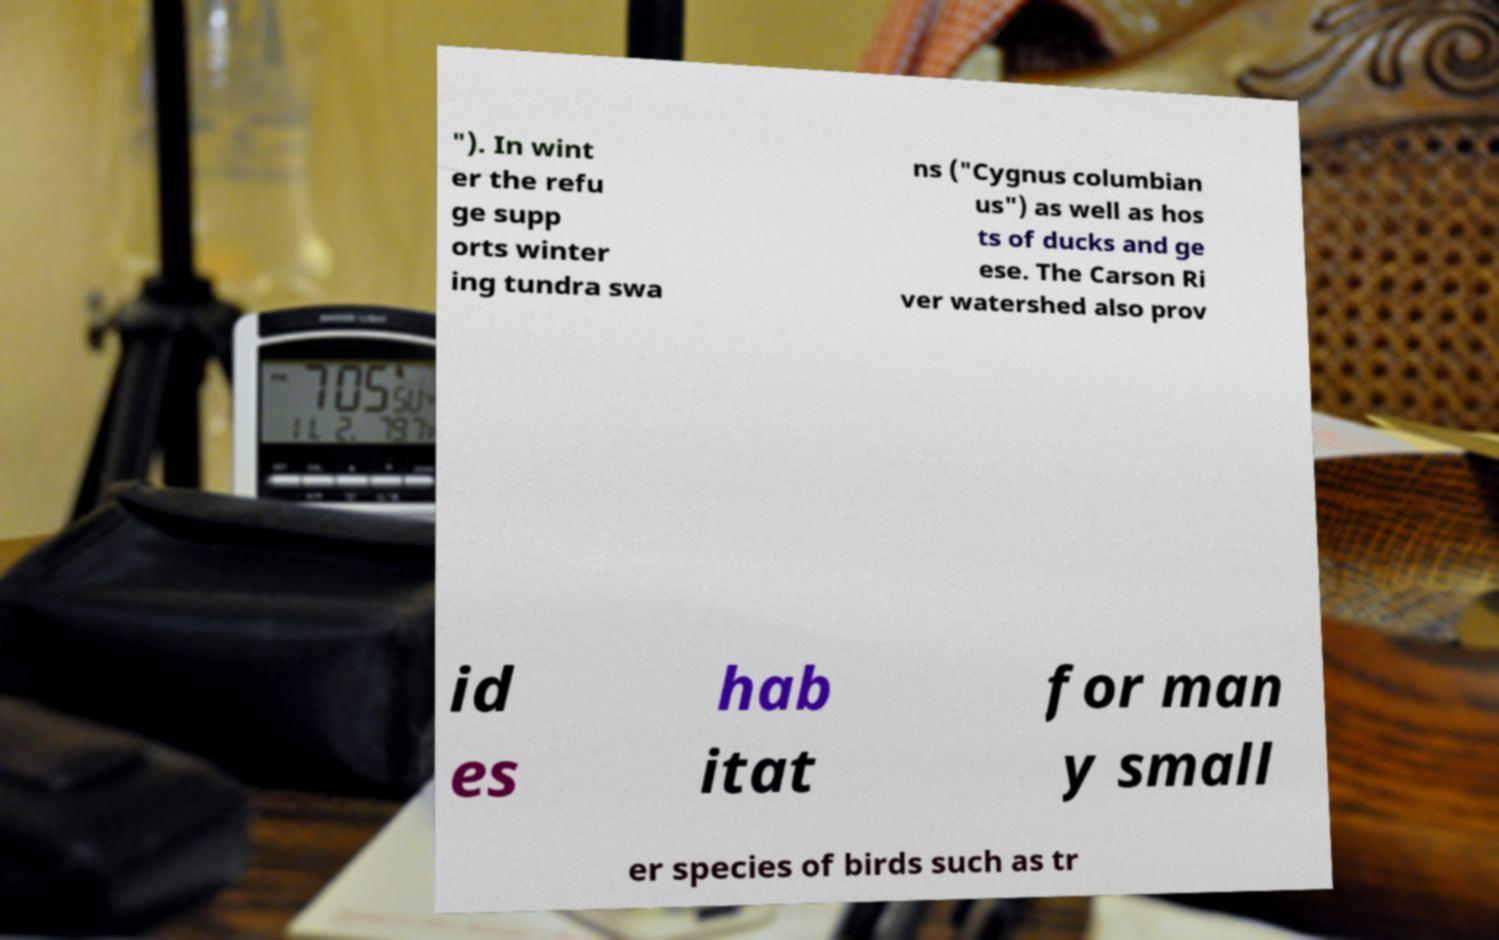Can you read and provide the text displayed in the image?This photo seems to have some interesting text. Can you extract and type it out for me? "). In wint er the refu ge supp orts winter ing tundra swa ns ("Cygnus columbian us") as well as hos ts of ducks and ge ese. The Carson Ri ver watershed also prov id es hab itat for man y small er species of birds such as tr 